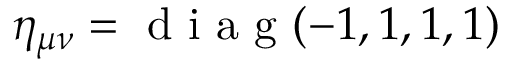Convert formula to latex. <formula><loc_0><loc_0><loc_500><loc_500>\eta _ { \mu \nu } = d i a g ( - 1 , 1 , 1 , 1 )</formula> 